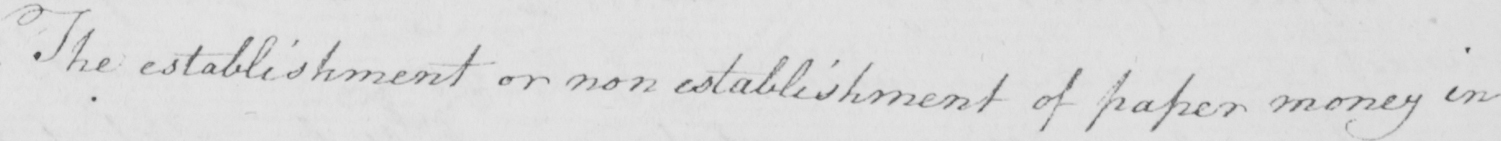What text is written in this handwritten line? The establishment or non establishment of paper money in 